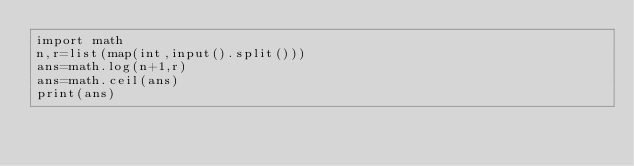Convert code to text. <code><loc_0><loc_0><loc_500><loc_500><_Python_>import math
n,r=list(map(int,input().split()))
ans=math.log(n+1,r)
ans=math.ceil(ans)
print(ans)</code> 